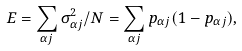Convert formula to latex. <formula><loc_0><loc_0><loc_500><loc_500>E = \sum _ { \alpha j } \sigma ^ { 2 } _ { \alpha j } / N = \sum _ { \alpha j } p _ { \alpha j } ( 1 - p _ { \alpha j } ) ,</formula> 